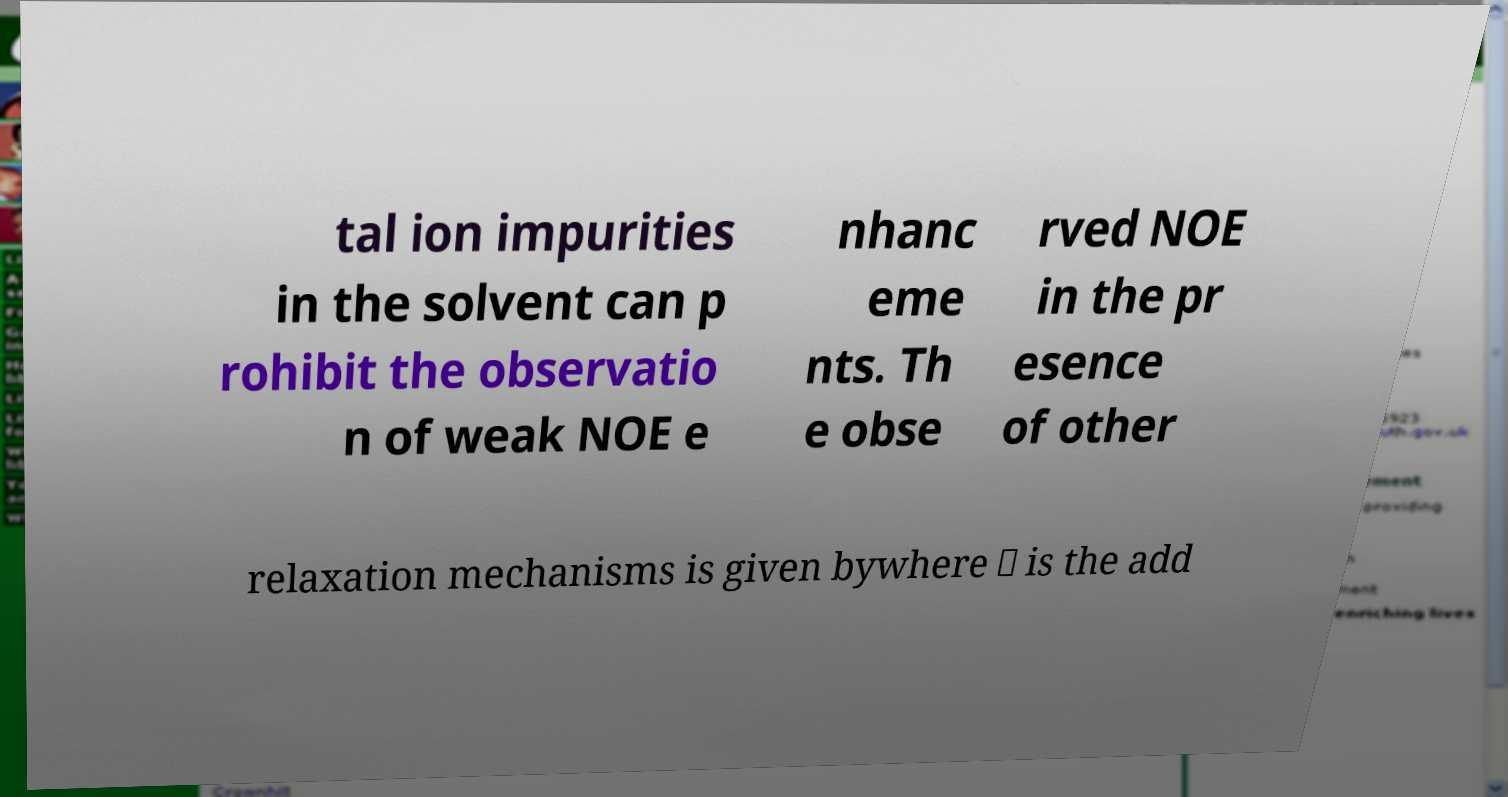Could you extract and type out the text from this image? tal ion impurities in the solvent can p rohibit the observatio n of weak NOE e nhanc eme nts. Th e obse rved NOE in the pr esence of other relaxation mechanisms is given bywhere ⋇ is the add 